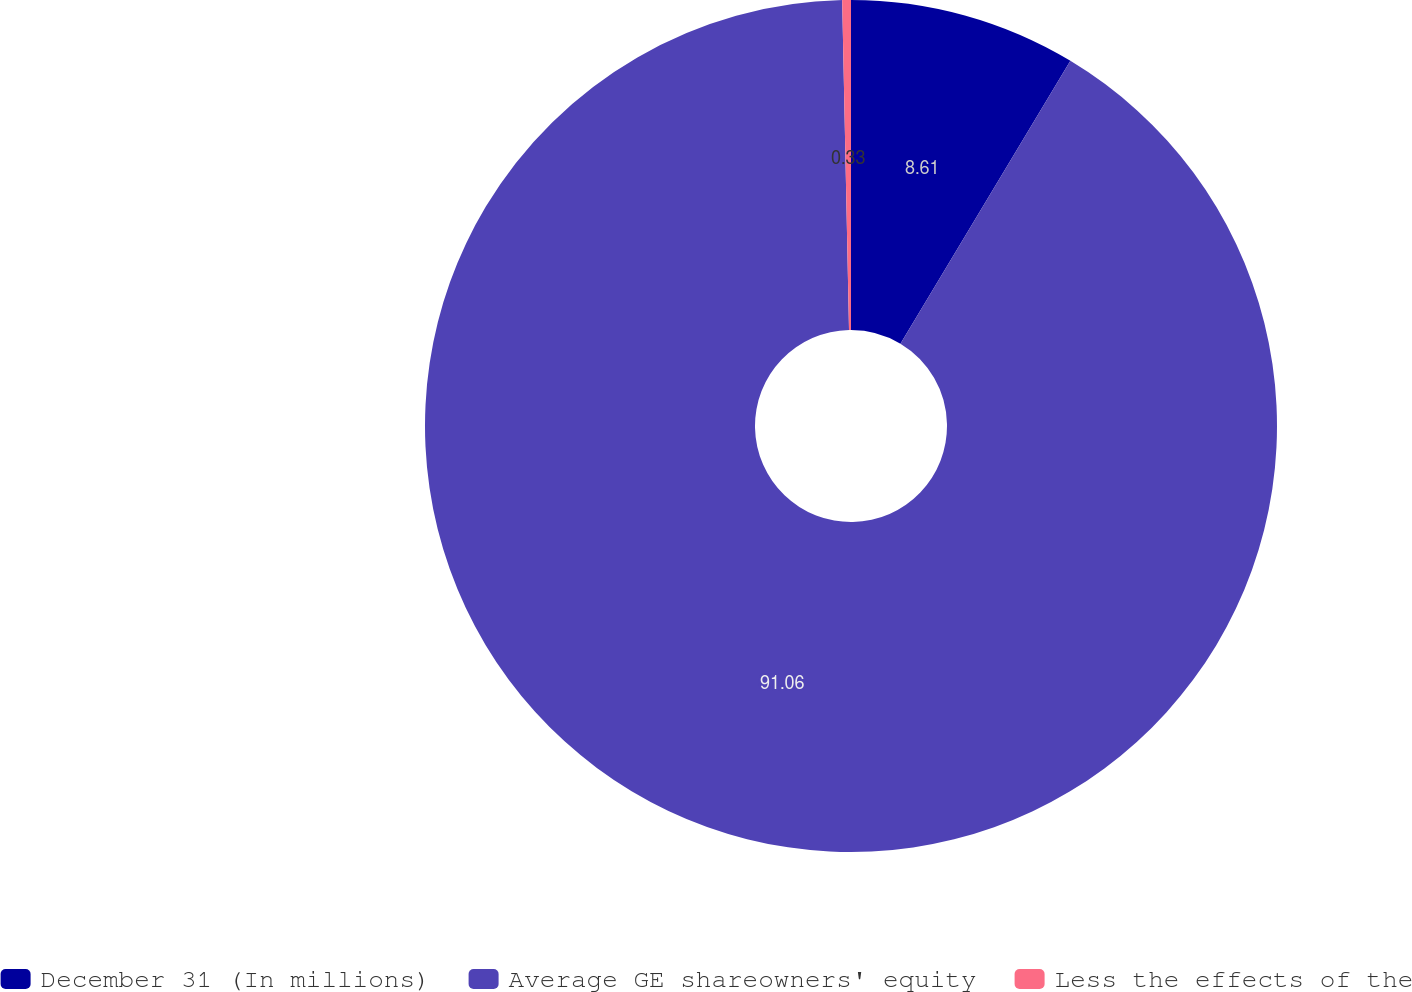Convert chart. <chart><loc_0><loc_0><loc_500><loc_500><pie_chart><fcel>December 31 (In millions)<fcel>Average GE shareowners' equity<fcel>Less the effects of the<nl><fcel>8.61%<fcel>91.06%<fcel>0.33%<nl></chart> 